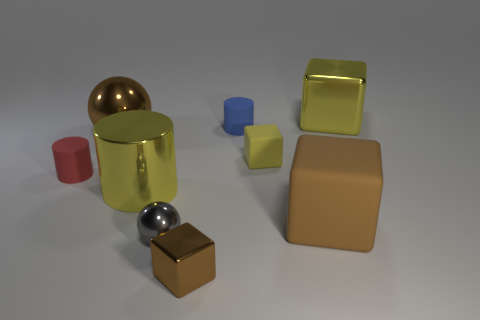There is a big metallic object that is in front of the big brown shiny object; does it have the same color as the metallic object that is on the right side of the small metallic block?
Your answer should be very brief. Yes. Is the color of the ball that is behind the tiny yellow matte cube the same as the large matte cube?
Provide a short and direct response. Yes. There is a big cube in front of the large yellow metallic object that is behind the red cylinder; what is it made of?
Offer a very short reply. Rubber. What material is the large thing that is the same color as the big shiny sphere?
Your answer should be compact. Rubber. What color is the big metallic cube?
Provide a short and direct response. Yellow. Is there a small object that is on the right side of the large shiny sphere that is behind the big rubber block?
Offer a very short reply. Yes. What is the large yellow cylinder made of?
Make the answer very short. Metal. Is the sphere that is right of the big sphere made of the same material as the cylinder that is behind the red thing?
Make the answer very short. No. Is there anything else that is the same color as the tiny metallic sphere?
Offer a terse response. No. What is the color of the other small matte object that is the same shape as the red object?
Provide a succinct answer. Blue. 